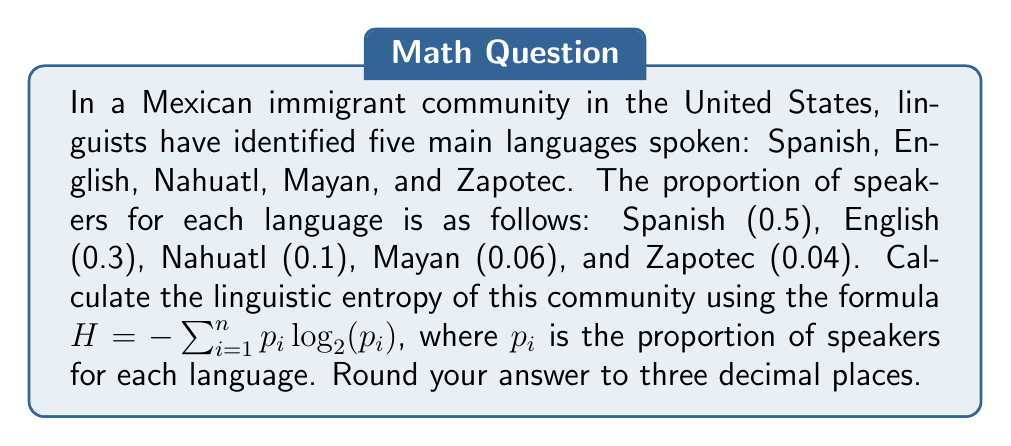Can you answer this question? To calculate the linguistic entropy, we'll use the given formula:

$H = -\sum_{i=1}^{n} p_i \log_2(p_i)$

Let's calculate each term separately:

1. Spanish: $-0.5 \log_2(0.5) = -0.5 \times (-1) = 0.5$
2. English: $-0.3 \log_2(0.3) = -0.3 \times (-1.737) = 0.5211$
3. Nahuatl: $-0.1 \log_2(0.1) = -0.1 \times (-3.322) = 0.3322$
4. Mayan: $-0.06 \log_2(0.06) = -0.06 \times (-4.059) = 0.2435$
5. Zapotec: $-0.04 \log_2(0.04) = -0.04 \times (-4.644) = 0.1858$

Now, we sum all these terms:

$H = 0.5 + 0.5211 + 0.3322 + 0.2435 + 0.1858 = 1.7826$

Rounding to three decimal places, we get 1.783.
Answer: 1.783 